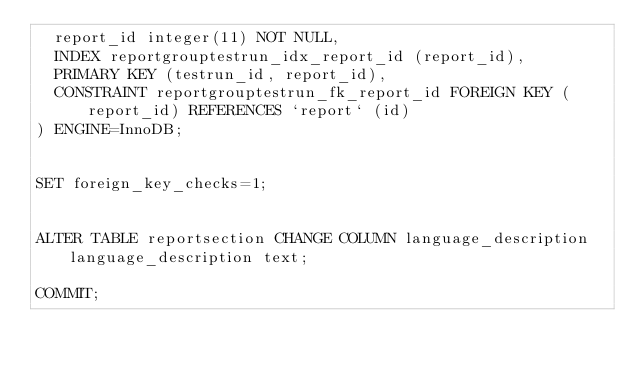<code> <loc_0><loc_0><loc_500><loc_500><_SQL_>  report_id integer(11) NOT NULL,
  INDEX reportgrouptestrun_idx_report_id (report_id),
  PRIMARY KEY (testrun_id, report_id),
  CONSTRAINT reportgrouptestrun_fk_report_id FOREIGN KEY (report_id) REFERENCES `report` (id)
) ENGINE=InnoDB;


SET foreign_key_checks=1;


ALTER TABLE reportsection CHANGE COLUMN language_description language_description text;

COMMIT;
</code> 